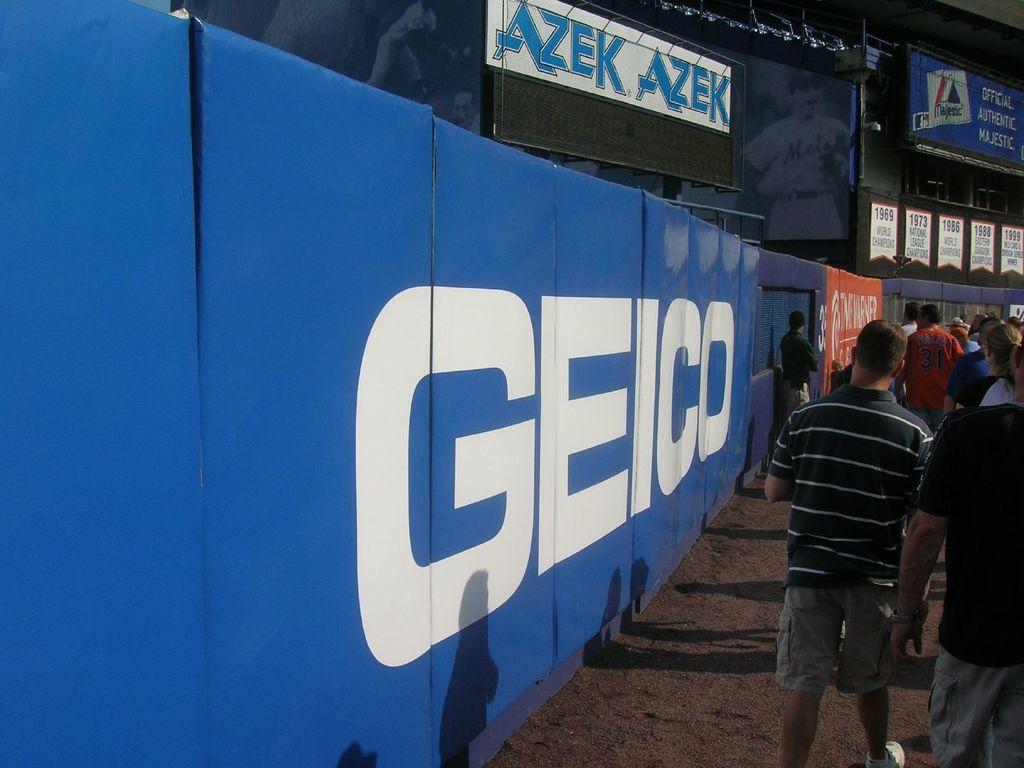How would you summarize this image in a sentence or two? In this image I can see number of people are standing. I can also see shadows, number of boards and on these boards I can see something is written. 